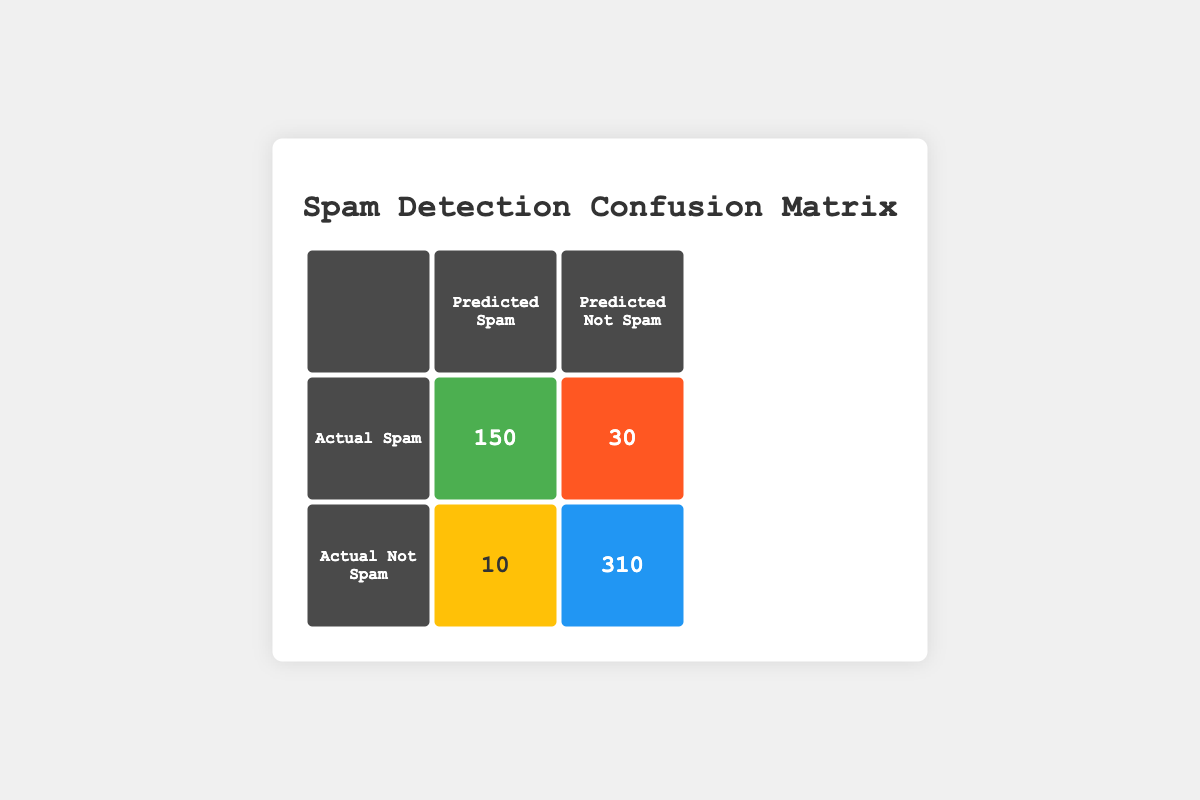What is the count of true positives in the confusion matrix? The true positive count refers to the value in the cell where actual spam and predicted spam intersect. From the table, that value is 150.
Answer: 150 What is the count of false negatives? The false negative count is found in the cell where actual spam intersects with predicted not spam. According to the table, this count is 30.
Answer: 30 What is the total number of emails classified as spam? To get the total classified as spam, add the true positives (150) and false negatives (30). Thus, the total becomes 150 + 30 = 180.
Answer: 180 What is the count of emails that were actually not spam and predicted as spam? The value corresponding to actual not spam and predicted spam is located in the table. This count is 10.
Answer: 10 Is the count of true negatives greater than the count of false positives? True negatives are represented as 310, which is greater than false positives at a count of 10, so the statement is true.
Answer: Yes What is the total number of correctly classified emails? Correctly classified emails include true positives (150) and true negatives (310). Adding these gives 150 + 310 = 460, thus the total is 460 emails.
Answer: 460 What is the ratio of false positives to the total number of emails classified as not spam? The total emails classified as not spam is the sum of true negatives (310) and false positives (10), amounting to 320. The ratio of false positives (10) over this total is calculated as 10/320, simplifying to 1/32.
Answer: 1/32 What is the combined count of emails predicted not spam? This is found by adding true negatives (310) and false negatives (30), resulting in 310 + 30 = 340 emails predicted as not spam.
Answer: 340 What percentage of actual spam emails were correctly classified as spam? To find the percentage, divide true positives (150) by the total actual spam (180) and multiply by 100. (150/180) * 100 ≈ 83.33%.
Answer: Approximately 83.33% 